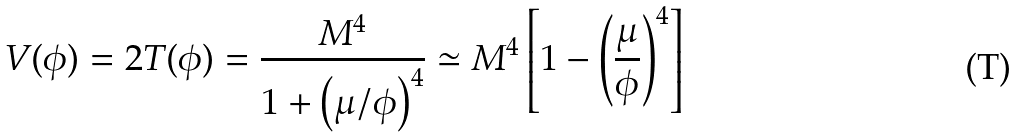Convert formula to latex. <formula><loc_0><loc_0><loc_500><loc_500>V ( \phi ) = 2 T ( \phi ) = \frac { M ^ { 4 } } { 1 + \left ( \mu / \phi \right ) ^ { 4 } } \simeq M ^ { 4 } \left [ 1 - \left ( \frac { \mu } { \phi } \right ) ^ { 4 } \right ]</formula> 